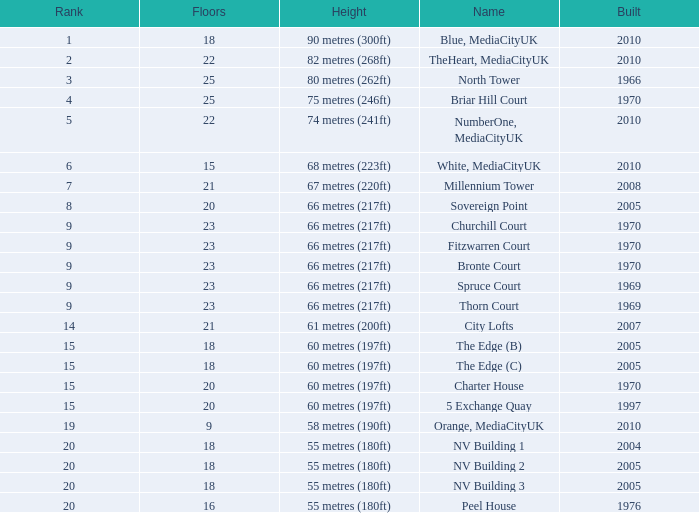What is the lowest Floors, when Built is greater than 1970, and when Name is NV Building 3? 18.0. 